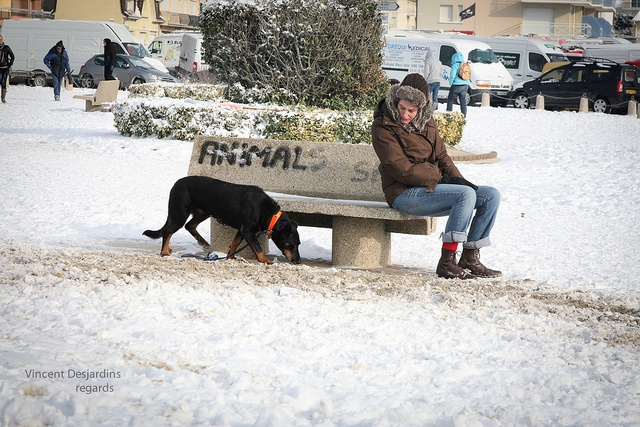Describe the objects in this image and their specific colors. I can see bench in tan, darkgray, gray, and black tones, people in tan, gray, black, and darkgray tones, dog in tan, black, maroon, gray, and brown tones, truck in tan, darkgray, lightgray, gray, and black tones, and car in tan, black, gray, darkgray, and lightgray tones in this image. 